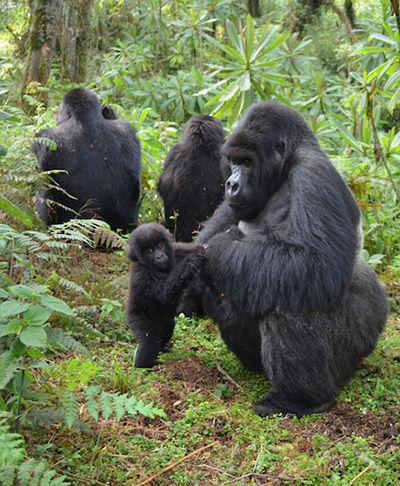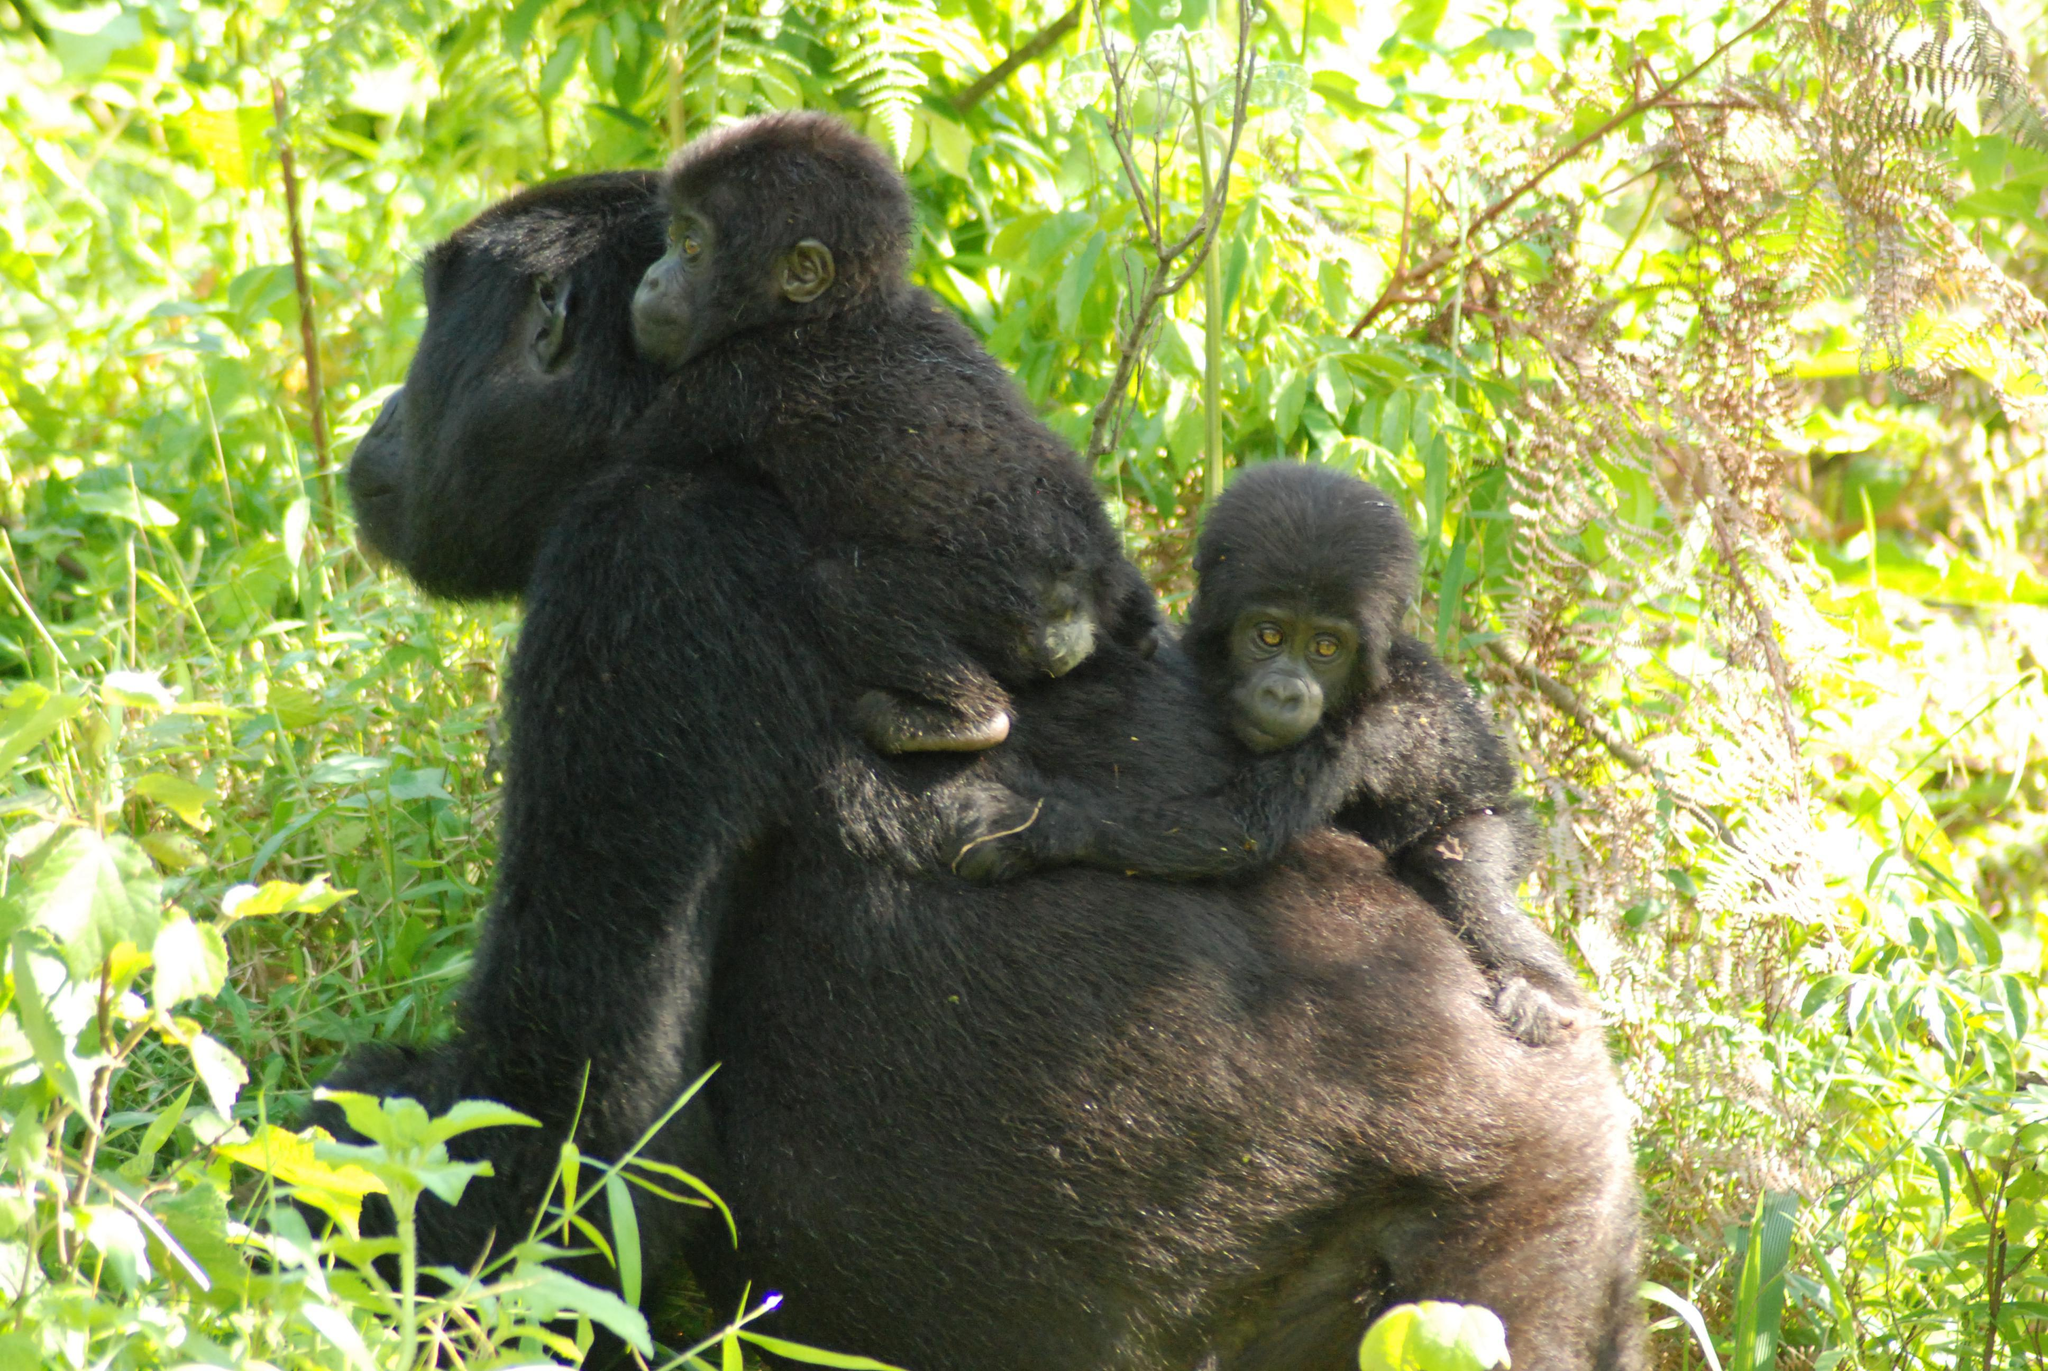The first image is the image on the left, the second image is the image on the right. Assess this claim about the two images: "Atleast 3 animals in every picture.". Correct or not? Answer yes or no. Yes. The first image is the image on the left, the second image is the image on the right. Examine the images to the left and right. Is the description "The image on the right shows at least one baby gorilla atop an adult gorilla that is not facing the camera." accurate? Answer yes or no. Yes. 